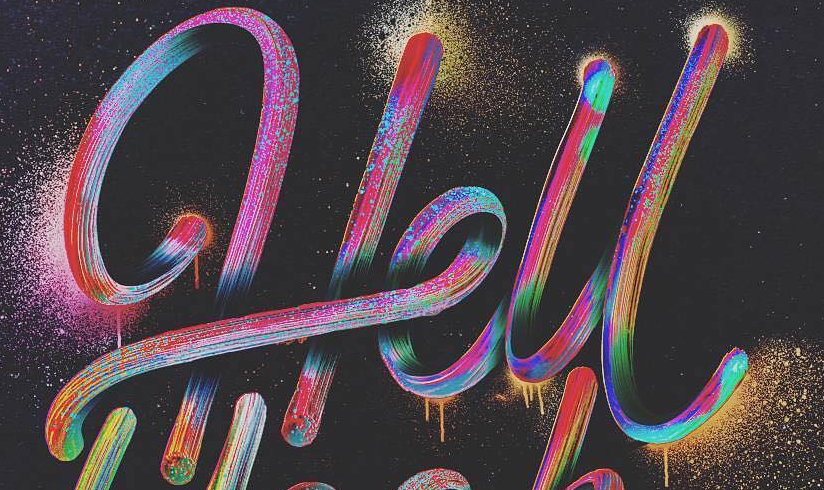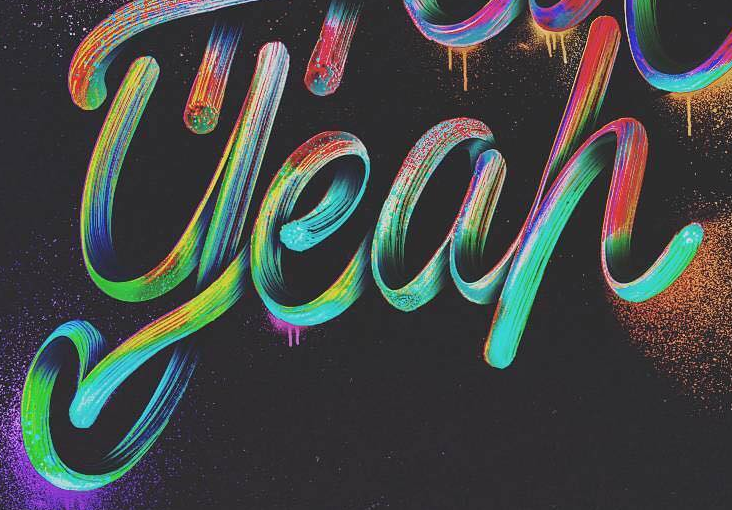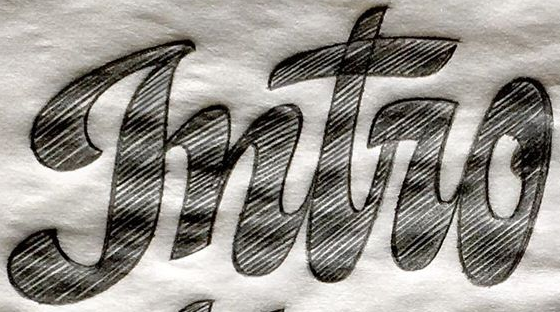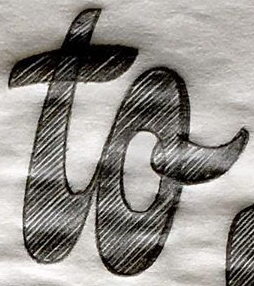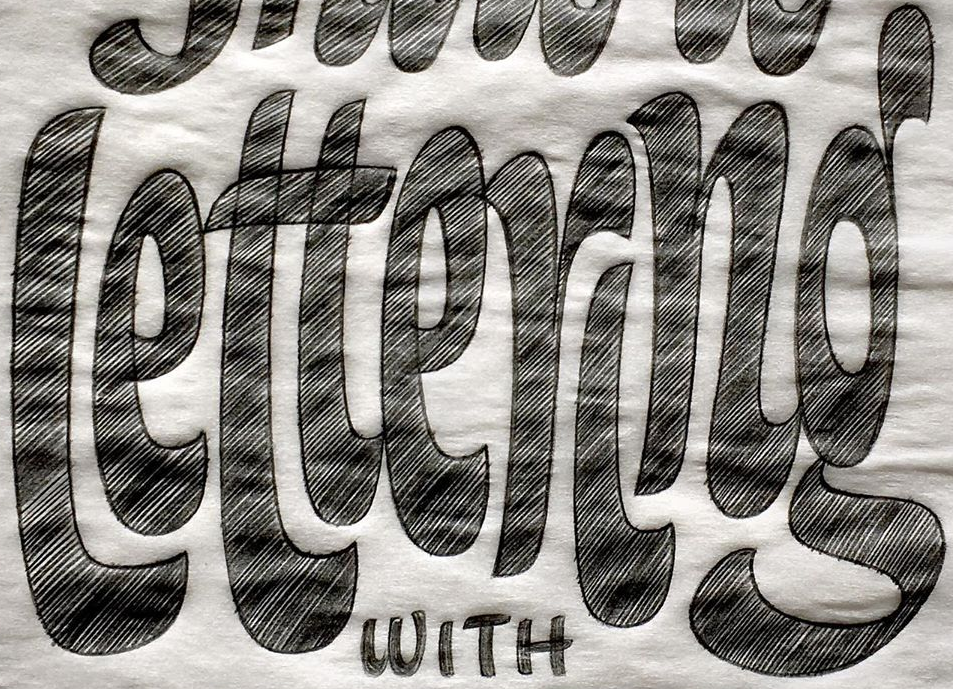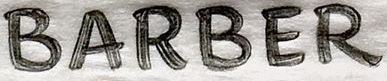What text appears in these images from left to right, separated by a semicolon? Hell; yeah; gntro; to; lettering; BARBER 